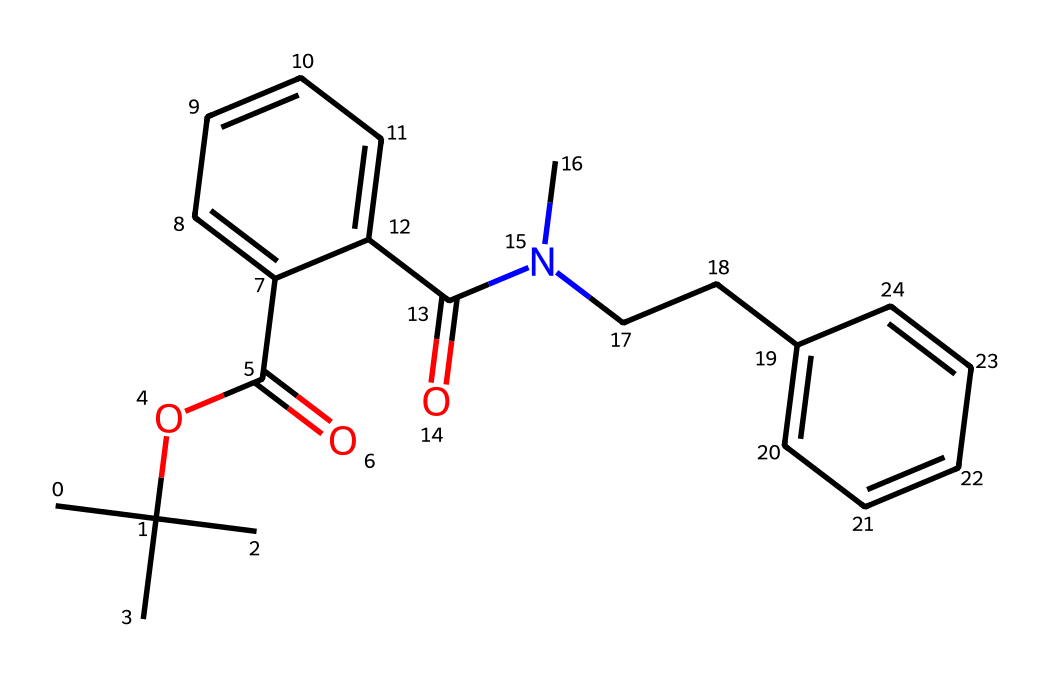How many carbon atoms are present in this chemical? The SMILES representation shows multiple 'C' characters, which represent carbon atoms. By counting each 'C', we find there are 21 carbon atoms in total.
Answer: 21 What type of functional group is present in this chemical? The chemical contains an ester group, indicated by the presence of 'OC(=O)' in the structure, which is characteristic of esters.
Answer: ester How many rings are in the structure? By analyzing the SMILES, we can see two occurrences of 'C1' and 'C2', indicating the presence of two cyclic structures or rings, making a total of two rings in the compound.
Answer: 2 What does the presence of nitrogen in the structure indicate? The nitrogen atom in the structure suggests that this chemical includes an amine or amide functional group. Since it is connected to a carbonyl, it indicates that it is part of an amide group.
Answer: amide What is a potential effect of taking this synthetic opioid? This chemical is a synthetic opioid, and it can cause respiratory depression, which is a significant risk associated with opioid use due to its effect on the central nervous system.
Answer: respiratory depression 